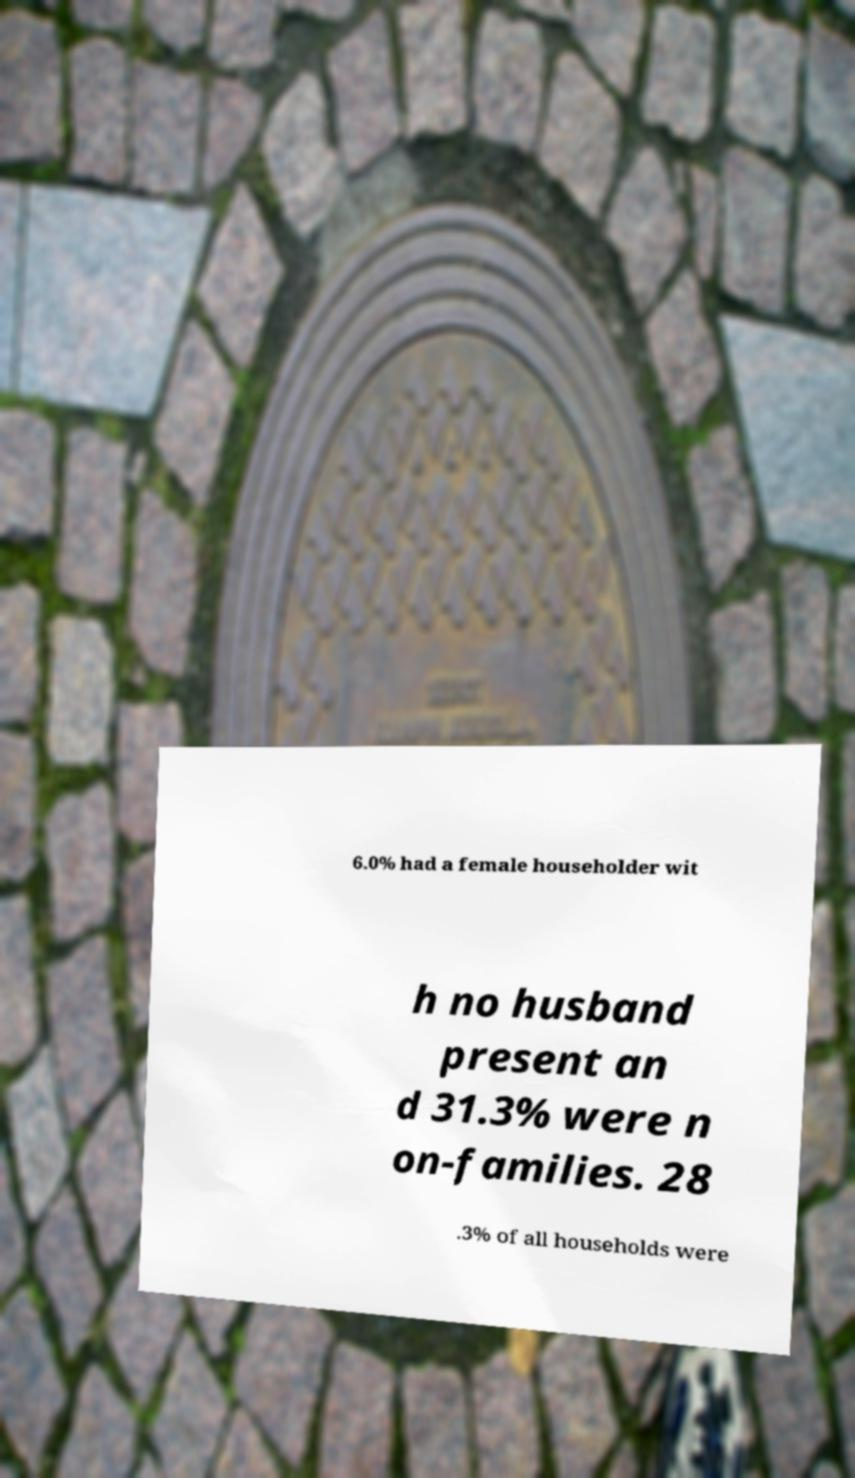Can you read and provide the text displayed in the image?This photo seems to have some interesting text. Can you extract and type it out for me? 6.0% had a female householder wit h no husband present an d 31.3% were n on-families. 28 .3% of all households were 